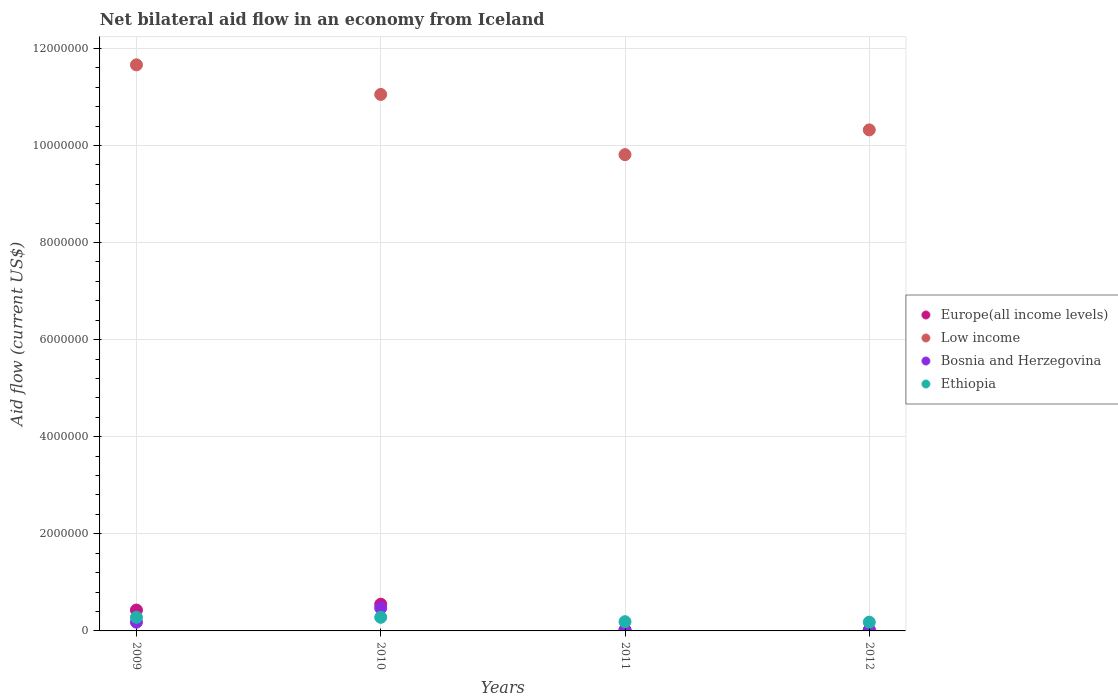How many different coloured dotlines are there?
Ensure brevity in your answer.  4. What is the total net bilateral aid flow in Europe(all income levels) in the graph?
Ensure brevity in your answer.  1.02e+06. What is the difference between the net bilateral aid flow in Low income in 2011 and the net bilateral aid flow in Ethiopia in 2010?
Make the answer very short. 9.53e+06. What is the average net bilateral aid flow in Bosnia and Herzegovina per year?
Your response must be concise. 1.72e+05. In how many years, is the net bilateral aid flow in Ethiopia greater than 4400000 US$?
Keep it short and to the point. 0. Is the difference between the net bilateral aid flow in Ethiopia in 2009 and 2010 greater than the difference between the net bilateral aid flow in Europe(all income levels) in 2009 and 2010?
Your response must be concise. Yes. Is the sum of the net bilateral aid flow in Bosnia and Herzegovina in 2010 and 2011 greater than the maximum net bilateral aid flow in Europe(all income levels) across all years?
Offer a very short reply. No. Is it the case that in every year, the sum of the net bilateral aid flow in Europe(all income levels) and net bilateral aid flow in Low income  is greater than the net bilateral aid flow in Ethiopia?
Make the answer very short. Yes. Is the net bilateral aid flow in Bosnia and Herzegovina strictly greater than the net bilateral aid flow in Low income over the years?
Offer a terse response. No. Is the net bilateral aid flow in Bosnia and Herzegovina strictly less than the net bilateral aid flow in Low income over the years?
Offer a very short reply. Yes. How many dotlines are there?
Make the answer very short. 4. What is the difference between two consecutive major ticks on the Y-axis?
Your response must be concise. 2.00e+06. Does the graph contain grids?
Keep it short and to the point. Yes. How many legend labels are there?
Provide a short and direct response. 4. What is the title of the graph?
Give a very brief answer. Net bilateral aid flow in an economy from Iceland. What is the label or title of the X-axis?
Offer a very short reply. Years. What is the label or title of the Y-axis?
Offer a very short reply. Aid flow (current US$). What is the Aid flow (current US$) in Europe(all income levels) in 2009?
Offer a very short reply. 4.30e+05. What is the Aid flow (current US$) of Low income in 2009?
Offer a very short reply. 1.17e+07. What is the Aid flow (current US$) in Bosnia and Herzegovina in 2009?
Make the answer very short. 1.80e+05. What is the Aid flow (current US$) of Europe(all income levels) in 2010?
Your answer should be compact. 5.50e+05. What is the Aid flow (current US$) in Low income in 2010?
Make the answer very short. 1.10e+07. What is the Aid flow (current US$) of Low income in 2011?
Keep it short and to the point. 9.81e+06. What is the Aid flow (current US$) of Bosnia and Herzegovina in 2011?
Your answer should be compact. 2.00e+04. What is the Aid flow (current US$) of Europe(all income levels) in 2012?
Offer a very short reply. 2.00e+04. What is the Aid flow (current US$) in Low income in 2012?
Your answer should be very brief. 1.03e+07. What is the Aid flow (current US$) in Ethiopia in 2012?
Offer a very short reply. 1.80e+05. Across all years, what is the maximum Aid flow (current US$) of Low income?
Ensure brevity in your answer.  1.17e+07. Across all years, what is the maximum Aid flow (current US$) of Bosnia and Herzegovina?
Provide a short and direct response. 4.70e+05. Across all years, what is the minimum Aid flow (current US$) in Low income?
Make the answer very short. 9.81e+06. What is the total Aid flow (current US$) in Europe(all income levels) in the graph?
Ensure brevity in your answer.  1.02e+06. What is the total Aid flow (current US$) of Low income in the graph?
Provide a short and direct response. 4.28e+07. What is the total Aid flow (current US$) in Bosnia and Herzegovina in the graph?
Offer a very short reply. 6.90e+05. What is the total Aid flow (current US$) of Ethiopia in the graph?
Provide a short and direct response. 9.30e+05. What is the difference between the Aid flow (current US$) of Europe(all income levels) in 2009 and that in 2010?
Offer a very short reply. -1.20e+05. What is the difference between the Aid flow (current US$) in Low income in 2009 and that in 2011?
Offer a very short reply. 1.85e+06. What is the difference between the Aid flow (current US$) in Low income in 2009 and that in 2012?
Your response must be concise. 1.34e+06. What is the difference between the Aid flow (current US$) in Ethiopia in 2009 and that in 2012?
Keep it short and to the point. 1.00e+05. What is the difference between the Aid flow (current US$) in Europe(all income levels) in 2010 and that in 2011?
Ensure brevity in your answer.  5.30e+05. What is the difference between the Aid flow (current US$) in Low income in 2010 and that in 2011?
Give a very brief answer. 1.24e+06. What is the difference between the Aid flow (current US$) in Bosnia and Herzegovina in 2010 and that in 2011?
Provide a short and direct response. 4.50e+05. What is the difference between the Aid flow (current US$) of Ethiopia in 2010 and that in 2011?
Provide a short and direct response. 9.00e+04. What is the difference between the Aid flow (current US$) of Europe(all income levels) in 2010 and that in 2012?
Offer a very short reply. 5.30e+05. What is the difference between the Aid flow (current US$) of Low income in 2010 and that in 2012?
Keep it short and to the point. 7.30e+05. What is the difference between the Aid flow (current US$) in Bosnia and Herzegovina in 2010 and that in 2012?
Offer a terse response. 4.50e+05. What is the difference between the Aid flow (current US$) of Europe(all income levels) in 2011 and that in 2012?
Offer a very short reply. 0. What is the difference between the Aid flow (current US$) in Low income in 2011 and that in 2012?
Offer a very short reply. -5.10e+05. What is the difference between the Aid flow (current US$) of Europe(all income levels) in 2009 and the Aid flow (current US$) of Low income in 2010?
Ensure brevity in your answer.  -1.06e+07. What is the difference between the Aid flow (current US$) in Europe(all income levels) in 2009 and the Aid flow (current US$) in Bosnia and Herzegovina in 2010?
Provide a succinct answer. -4.00e+04. What is the difference between the Aid flow (current US$) in Low income in 2009 and the Aid flow (current US$) in Bosnia and Herzegovina in 2010?
Your answer should be compact. 1.12e+07. What is the difference between the Aid flow (current US$) of Low income in 2009 and the Aid flow (current US$) of Ethiopia in 2010?
Your answer should be very brief. 1.14e+07. What is the difference between the Aid flow (current US$) in Bosnia and Herzegovina in 2009 and the Aid flow (current US$) in Ethiopia in 2010?
Offer a terse response. -1.00e+05. What is the difference between the Aid flow (current US$) of Europe(all income levels) in 2009 and the Aid flow (current US$) of Low income in 2011?
Offer a very short reply. -9.38e+06. What is the difference between the Aid flow (current US$) of Europe(all income levels) in 2009 and the Aid flow (current US$) of Bosnia and Herzegovina in 2011?
Your answer should be very brief. 4.10e+05. What is the difference between the Aid flow (current US$) in Low income in 2009 and the Aid flow (current US$) in Bosnia and Herzegovina in 2011?
Your answer should be very brief. 1.16e+07. What is the difference between the Aid flow (current US$) of Low income in 2009 and the Aid flow (current US$) of Ethiopia in 2011?
Your answer should be compact. 1.15e+07. What is the difference between the Aid flow (current US$) of Europe(all income levels) in 2009 and the Aid flow (current US$) of Low income in 2012?
Your answer should be very brief. -9.89e+06. What is the difference between the Aid flow (current US$) in Europe(all income levels) in 2009 and the Aid flow (current US$) in Ethiopia in 2012?
Your answer should be very brief. 2.50e+05. What is the difference between the Aid flow (current US$) of Low income in 2009 and the Aid flow (current US$) of Bosnia and Herzegovina in 2012?
Offer a terse response. 1.16e+07. What is the difference between the Aid flow (current US$) of Low income in 2009 and the Aid flow (current US$) of Ethiopia in 2012?
Make the answer very short. 1.15e+07. What is the difference between the Aid flow (current US$) of Europe(all income levels) in 2010 and the Aid flow (current US$) of Low income in 2011?
Offer a very short reply. -9.26e+06. What is the difference between the Aid flow (current US$) of Europe(all income levels) in 2010 and the Aid flow (current US$) of Bosnia and Herzegovina in 2011?
Your response must be concise. 5.30e+05. What is the difference between the Aid flow (current US$) in Europe(all income levels) in 2010 and the Aid flow (current US$) in Ethiopia in 2011?
Your answer should be very brief. 3.60e+05. What is the difference between the Aid flow (current US$) in Low income in 2010 and the Aid flow (current US$) in Bosnia and Herzegovina in 2011?
Provide a succinct answer. 1.10e+07. What is the difference between the Aid flow (current US$) in Low income in 2010 and the Aid flow (current US$) in Ethiopia in 2011?
Make the answer very short. 1.09e+07. What is the difference between the Aid flow (current US$) in Europe(all income levels) in 2010 and the Aid flow (current US$) in Low income in 2012?
Your answer should be very brief. -9.77e+06. What is the difference between the Aid flow (current US$) of Europe(all income levels) in 2010 and the Aid flow (current US$) of Bosnia and Herzegovina in 2012?
Keep it short and to the point. 5.30e+05. What is the difference between the Aid flow (current US$) of Low income in 2010 and the Aid flow (current US$) of Bosnia and Herzegovina in 2012?
Keep it short and to the point. 1.10e+07. What is the difference between the Aid flow (current US$) in Low income in 2010 and the Aid flow (current US$) in Ethiopia in 2012?
Offer a very short reply. 1.09e+07. What is the difference between the Aid flow (current US$) of Bosnia and Herzegovina in 2010 and the Aid flow (current US$) of Ethiopia in 2012?
Offer a terse response. 2.90e+05. What is the difference between the Aid flow (current US$) of Europe(all income levels) in 2011 and the Aid flow (current US$) of Low income in 2012?
Ensure brevity in your answer.  -1.03e+07. What is the difference between the Aid flow (current US$) in Europe(all income levels) in 2011 and the Aid flow (current US$) in Bosnia and Herzegovina in 2012?
Your answer should be very brief. 0. What is the difference between the Aid flow (current US$) in Europe(all income levels) in 2011 and the Aid flow (current US$) in Ethiopia in 2012?
Ensure brevity in your answer.  -1.60e+05. What is the difference between the Aid flow (current US$) in Low income in 2011 and the Aid flow (current US$) in Bosnia and Herzegovina in 2012?
Provide a succinct answer. 9.79e+06. What is the difference between the Aid flow (current US$) of Low income in 2011 and the Aid flow (current US$) of Ethiopia in 2012?
Your answer should be compact. 9.63e+06. What is the average Aid flow (current US$) in Europe(all income levels) per year?
Your response must be concise. 2.55e+05. What is the average Aid flow (current US$) of Low income per year?
Your answer should be compact. 1.07e+07. What is the average Aid flow (current US$) of Bosnia and Herzegovina per year?
Ensure brevity in your answer.  1.72e+05. What is the average Aid flow (current US$) in Ethiopia per year?
Your answer should be very brief. 2.32e+05. In the year 2009, what is the difference between the Aid flow (current US$) in Europe(all income levels) and Aid flow (current US$) in Low income?
Give a very brief answer. -1.12e+07. In the year 2009, what is the difference between the Aid flow (current US$) in Europe(all income levels) and Aid flow (current US$) in Bosnia and Herzegovina?
Offer a very short reply. 2.50e+05. In the year 2009, what is the difference between the Aid flow (current US$) of Low income and Aid flow (current US$) of Bosnia and Herzegovina?
Your answer should be very brief. 1.15e+07. In the year 2009, what is the difference between the Aid flow (current US$) of Low income and Aid flow (current US$) of Ethiopia?
Your answer should be very brief. 1.14e+07. In the year 2010, what is the difference between the Aid flow (current US$) in Europe(all income levels) and Aid flow (current US$) in Low income?
Provide a succinct answer. -1.05e+07. In the year 2010, what is the difference between the Aid flow (current US$) of Europe(all income levels) and Aid flow (current US$) of Bosnia and Herzegovina?
Offer a terse response. 8.00e+04. In the year 2010, what is the difference between the Aid flow (current US$) of Europe(all income levels) and Aid flow (current US$) of Ethiopia?
Ensure brevity in your answer.  2.70e+05. In the year 2010, what is the difference between the Aid flow (current US$) in Low income and Aid flow (current US$) in Bosnia and Herzegovina?
Your response must be concise. 1.06e+07. In the year 2010, what is the difference between the Aid flow (current US$) in Low income and Aid flow (current US$) in Ethiopia?
Give a very brief answer. 1.08e+07. In the year 2011, what is the difference between the Aid flow (current US$) in Europe(all income levels) and Aid flow (current US$) in Low income?
Ensure brevity in your answer.  -9.79e+06. In the year 2011, what is the difference between the Aid flow (current US$) of Europe(all income levels) and Aid flow (current US$) of Bosnia and Herzegovina?
Offer a terse response. 0. In the year 2011, what is the difference between the Aid flow (current US$) in Europe(all income levels) and Aid flow (current US$) in Ethiopia?
Make the answer very short. -1.70e+05. In the year 2011, what is the difference between the Aid flow (current US$) in Low income and Aid flow (current US$) in Bosnia and Herzegovina?
Provide a succinct answer. 9.79e+06. In the year 2011, what is the difference between the Aid flow (current US$) in Low income and Aid flow (current US$) in Ethiopia?
Offer a very short reply. 9.62e+06. In the year 2012, what is the difference between the Aid flow (current US$) of Europe(all income levels) and Aid flow (current US$) of Low income?
Make the answer very short. -1.03e+07. In the year 2012, what is the difference between the Aid flow (current US$) of Europe(all income levels) and Aid flow (current US$) of Bosnia and Herzegovina?
Ensure brevity in your answer.  0. In the year 2012, what is the difference between the Aid flow (current US$) of Europe(all income levels) and Aid flow (current US$) of Ethiopia?
Provide a short and direct response. -1.60e+05. In the year 2012, what is the difference between the Aid flow (current US$) of Low income and Aid flow (current US$) of Bosnia and Herzegovina?
Provide a succinct answer. 1.03e+07. In the year 2012, what is the difference between the Aid flow (current US$) in Low income and Aid flow (current US$) in Ethiopia?
Your answer should be compact. 1.01e+07. In the year 2012, what is the difference between the Aid flow (current US$) in Bosnia and Herzegovina and Aid flow (current US$) in Ethiopia?
Provide a succinct answer. -1.60e+05. What is the ratio of the Aid flow (current US$) in Europe(all income levels) in 2009 to that in 2010?
Your answer should be very brief. 0.78. What is the ratio of the Aid flow (current US$) of Low income in 2009 to that in 2010?
Make the answer very short. 1.06. What is the ratio of the Aid flow (current US$) of Bosnia and Herzegovina in 2009 to that in 2010?
Your response must be concise. 0.38. What is the ratio of the Aid flow (current US$) of Ethiopia in 2009 to that in 2010?
Provide a succinct answer. 1. What is the ratio of the Aid flow (current US$) of Europe(all income levels) in 2009 to that in 2011?
Ensure brevity in your answer.  21.5. What is the ratio of the Aid flow (current US$) in Low income in 2009 to that in 2011?
Make the answer very short. 1.19. What is the ratio of the Aid flow (current US$) in Bosnia and Herzegovina in 2009 to that in 2011?
Keep it short and to the point. 9. What is the ratio of the Aid flow (current US$) of Ethiopia in 2009 to that in 2011?
Offer a very short reply. 1.47. What is the ratio of the Aid flow (current US$) of Low income in 2009 to that in 2012?
Give a very brief answer. 1.13. What is the ratio of the Aid flow (current US$) of Ethiopia in 2009 to that in 2012?
Make the answer very short. 1.56. What is the ratio of the Aid flow (current US$) in Europe(all income levels) in 2010 to that in 2011?
Give a very brief answer. 27.5. What is the ratio of the Aid flow (current US$) in Low income in 2010 to that in 2011?
Ensure brevity in your answer.  1.13. What is the ratio of the Aid flow (current US$) of Bosnia and Herzegovina in 2010 to that in 2011?
Ensure brevity in your answer.  23.5. What is the ratio of the Aid flow (current US$) of Ethiopia in 2010 to that in 2011?
Offer a very short reply. 1.47. What is the ratio of the Aid flow (current US$) of Europe(all income levels) in 2010 to that in 2012?
Offer a terse response. 27.5. What is the ratio of the Aid flow (current US$) of Low income in 2010 to that in 2012?
Offer a terse response. 1.07. What is the ratio of the Aid flow (current US$) of Bosnia and Herzegovina in 2010 to that in 2012?
Make the answer very short. 23.5. What is the ratio of the Aid flow (current US$) in Ethiopia in 2010 to that in 2012?
Provide a succinct answer. 1.56. What is the ratio of the Aid flow (current US$) of Low income in 2011 to that in 2012?
Give a very brief answer. 0.95. What is the ratio of the Aid flow (current US$) in Bosnia and Herzegovina in 2011 to that in 2012?
Your response must be concise. 1. What is the ratio of the Aid flow (current US$) of Ethiopia in 2011 to that in 2012?
Your response must be concise. 1.06. What is the difference between the highest and the second highest Aid flow (current US$) of Low income?
Keep it short and to the point. 6.10e+05. What is the difference between the highest and the second highest Aid flow (current US$) of Bosnia and Herzegovina?
Offer a very short reply. 2.90e+05. What is the difference between the highest and the lowest Aid flow (current US$) of Europe(all income levels)?
Offer a terse response. 5.30e+05. What is the difference between the highest and the lowest Aid flow (current US$) in Low income?
Provide a short and direct response. 1.85e+06. What is the difference between the highest and the lowest Aid flow (current US$) of Bosnia and Herzegovina?
Your answer should be very brief. 4.50e+05. 